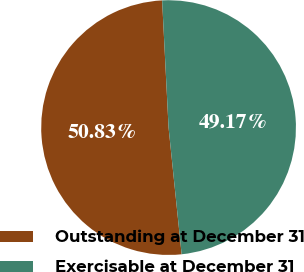Convert chart. <chart><loc_0><loc_0><loc_500><loc_500><pie_chart><fcel>Outstanding at December 31<fcel>Exercisable at December 31<nl><fcel>50.83%<fcel>49.17%<nl></chart> 